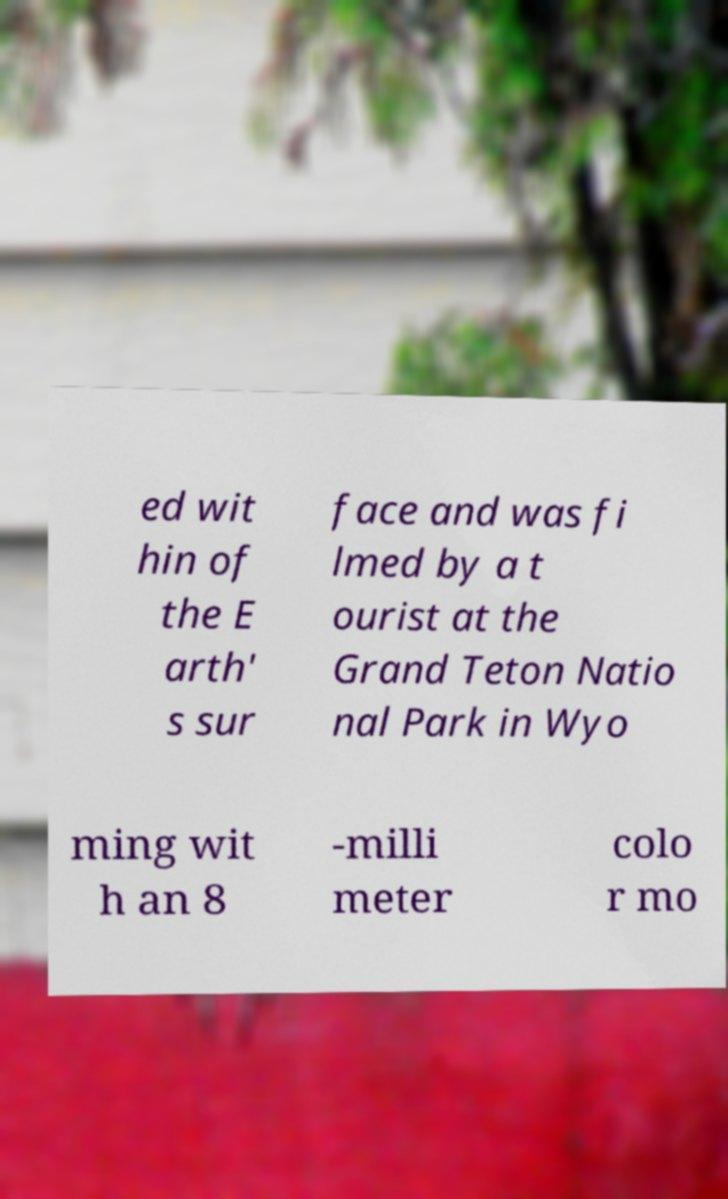Can you read and provide the text displayed in the image?This photo seems to have some interesting text. Can you extract and type it out for me? ed wit hin of the E arth' s sur face and was fi lmed by a t ourist at the Grand Teton Natio nal Park in Wyo ming wit h an 8 -milli meter colo r mo 